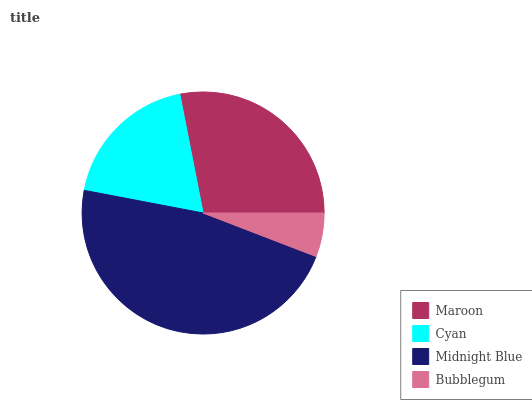Is Bubblegum the minimum?
Answer yes or no. Yes. Is Midnight Blue the maximum?
Answer yes or no. Yes. Is Cyan the minimum?
Answer yes or no. No. Is Cyan the maximum?
Answer yes or no. No. Is Maroon greater than Cyan?
Answer yes or no. Yes. Is Cyan less than Maroon?
Answer yes or no. Yes. Is Cyan greater than Maroon?
Answer yes or no. No. Is Maroon less than Cyan?
Answer yes or no. No. Is Maroon the high median?
Answer yes or no. Yes. Is Cyan the low median?
Answer yes or no. Yes. Is Cyan the high median?
Answer yes or no. No. Is Bubblegum the low median?
Answer yes or no. No. 